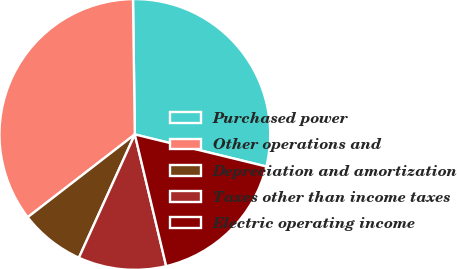Convert chart to OTSL. <chart><loc_0><loc_0><loc_500><loc_500><pie_chart><fcel>Purchased power<fcel>Other operations and<fcel>Depreciation and amortization<fcel>Taxes other than income taxes<fcel>Electric operating income<nl><fcel>29.02%<fcel>35.25%<fcel>7.75%<fcel>10.5%<fcel>17.47%<nl></chart> 